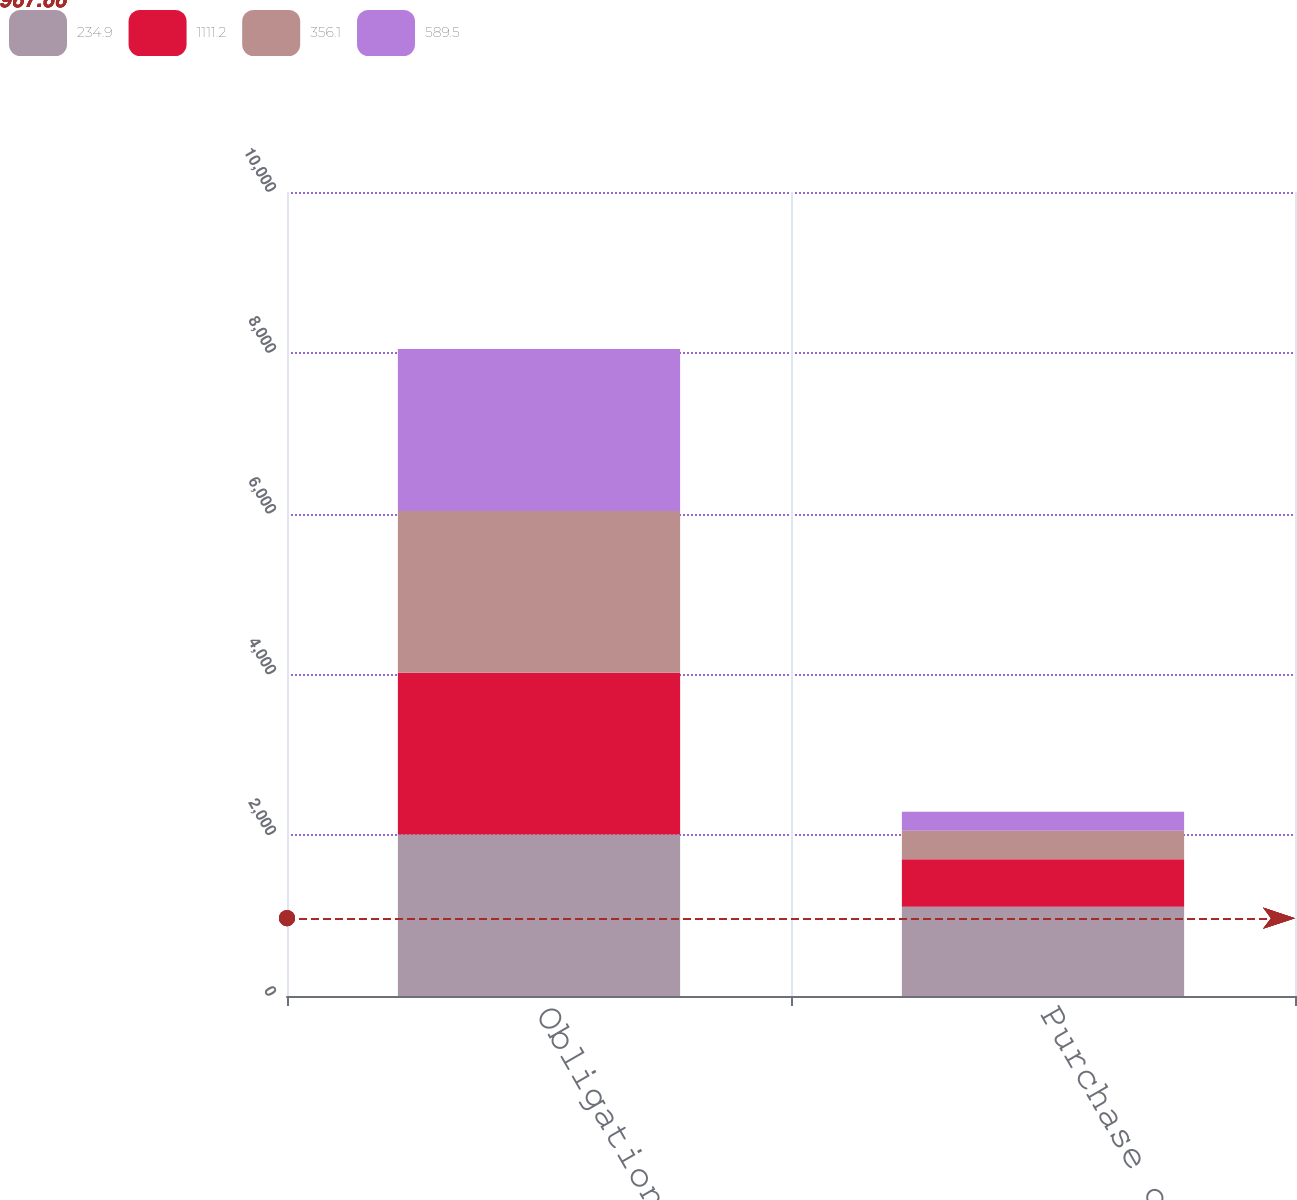Convert chart to OTSL. <chart><loc_0><loc_0><loc_500><loc_500><stacked_bar_chart><ecel><fcel>Obligations<fcel>Purchase obligations<nl><fcel>234.9<fcel>2010<fcel>1111.2<nl><fcel>1111.2<fcel>2011<fcel>589.5<nl><fcel>356.1<fcel>2012<fcel>356.1<nl><fcel>589.5<fcel>2013<fcel>234.9<nl></chart> 